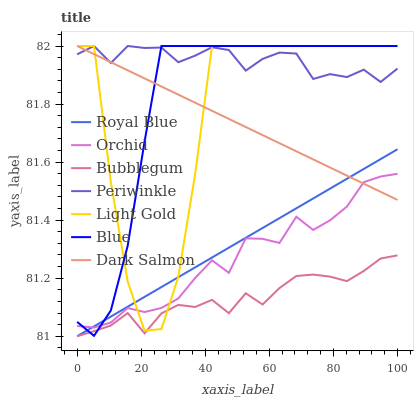Does Bubblegum have the minimum area under the curve?
Answer yes or no. Yes. Does Periwinkle have the maximum area under the curve?
Answer yes or no. Yes. Does Dark Salmon have the minimum area under the curve?
Answer yes or no. No. Does Dark Salmon have the maximum area under the curve?
Answer yes or no. No. Is Royal Blue the smoothest?
Answer yes or no. Yes. Is Light Gold the roughest?
Answer yes or no. Yes. Is Dark Salmon the smoothest?
Answer yes or no. No. Is Dark Salmon the roughest?
Answer yes or no. No. Does Bubblegum have the lowest value?
Answer yes or no. Yes. Does Dark Salmon have the lowest value?
Answer yes or no. No. Does Light Gold have the highest value?
Answer yes or no. Yes. Does Bubblegum have the highest value?
Answer yes or no. No. Is Bubblegum less than Dark Salmon?
Answer yes or no. Yes. Is Periwinkle greater than Royal Blue?
Answer yes or no. Yes. Does Blue intersect Bubblegum?
Answer yes or no. Yes. Is Blue less than Bubblegum?
Answer yes or no. No. Is Blue greater than Bubblegum?
Answer yes or no. No. Does Bubblegum intersect Dark Salmon?
Answer yes or no. No. 